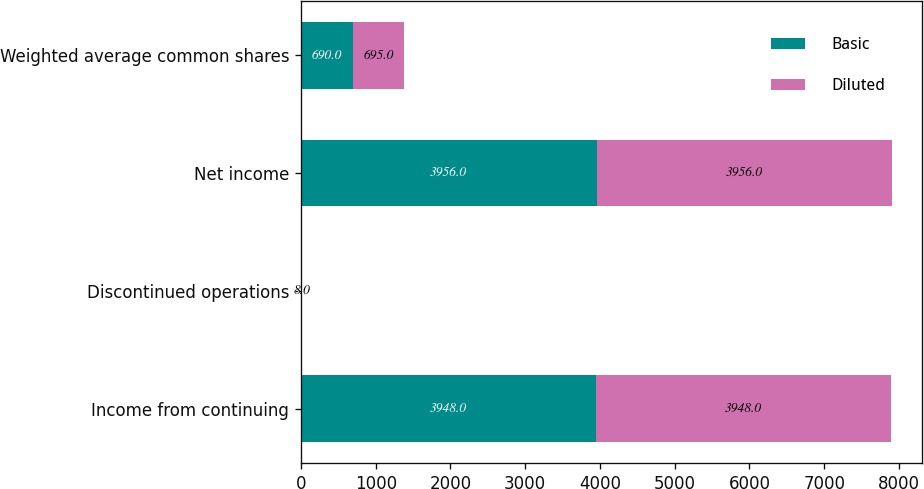<chart> <loc_0><loc_0><loc_500><loc_500><stacked_bar_chart><ecel><fcel>Income from continuing<fcel>Discontinued operations<fcel>Net income<fcel>Weighted average common shares<nl><fcel>Basic<fcel>3948<fcel>8<fcel>3956<fcel>690<nl><fcel>Diluted<fcel>3948<fcel>8<fcel>3956<fcel>695<nl></chart> 